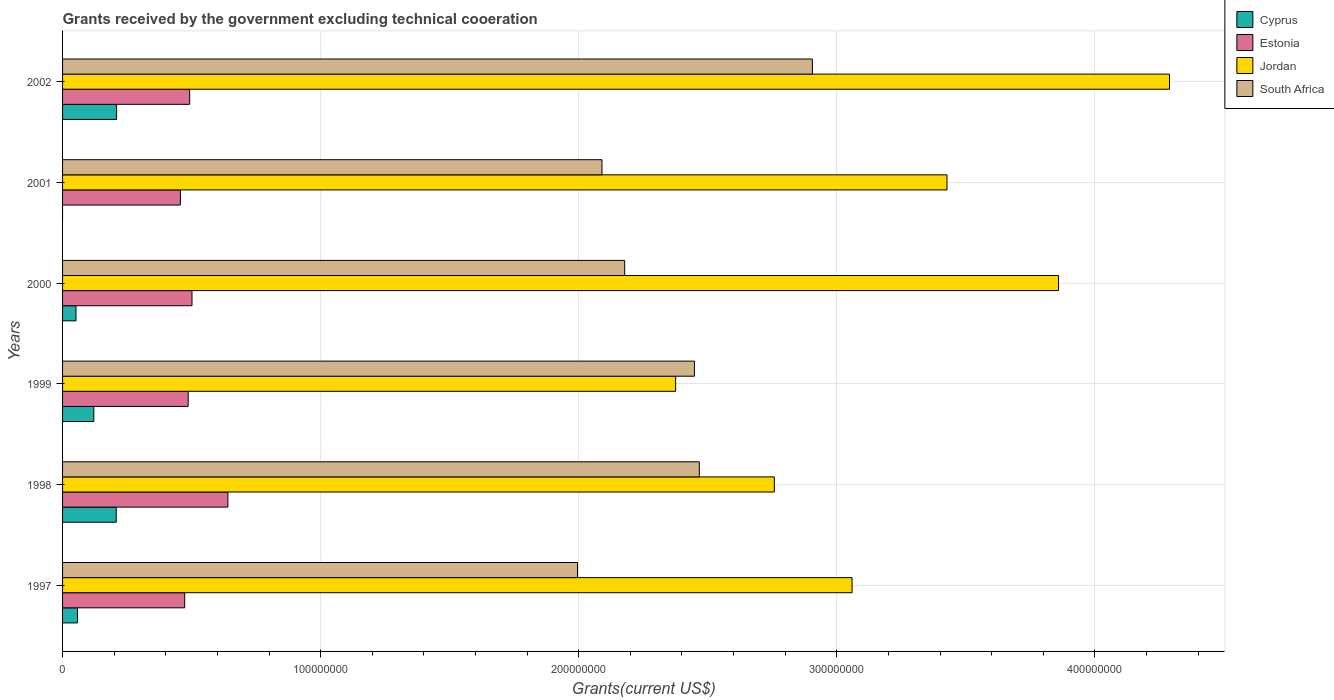How many different coloured bars are there?
Make the answer very short. 4. Are the number of bars per tick equal to the number of legend labels?
Keep it short and to the point. No. Are the number of bars on each tick of the Y-axis equal?
Your answer should be very brief. No. How many bars are there on the 1st tick from the top?
Your response must be concise. 4. How many bars are there on the 3rd tick from the bottom?
Your answer should be very brief. 4. In how many cases, is the number of bars for a given year not equal to the number of legend labels?
Your answer should be compact. 1. What is the total grants received by the government in South Africa in 1997?
Provide a short and direct response. 2.00e+08. Across all years, what is the maximum total grants received by the government in Cyprus?
Offer a very short reply. 2.09e+07. Across all years, what is the minimum total grants received by the government in South Africa?
Keep it short and to the point. 2.00e+08. What is the total total grants received by the government in Jordan in the graph?
Your answer should be compact. 1.98e+09. What is the difference between the total grants received by the government in Jordan in 1998 and the total grants received by the government in Estonia in 2002?
Provide a succinct answer. 2.27e+08. What is the average total grants received by the government in Jordan per year?
Provide a short and direct response. 3.29e+08. In the year 1998, what is the difference between the total grants received by the government in Jordan and total grants received by the government in Cyprus?
Ensure brevity in your answer.  2.55e+08. In how many years, is the total grants received by the government in South Africa greater than 200000000 US$?
Offer a very short reply. 5. What is the ratio of the total grants received by the government in Estonia in 1997 to that in 2001?
Your response must be concise. 1.04. Is the difference between the total grants received by the government in Jordan in 1999 and 2002 greater than the difference between the total grants received by the government in Cyprus in 1999 and 2002?
Offer a very short reply. No. What is the difference between the highest and the second highest total grants received by the government in South Africa?
Give a very brief answer. 4.38e+07. What is the difference between the highest and the lowest total grants received by the government in Estonia?
Give a very brief answer. 1.84e+07. Is it the case that in every year, the sum of the total grants received by the government in Cyprus and total grants received by the government in Estonia is greater than the total grants received by the government in South Africa?
Keep it short and to the point. No. How many bars are there?
Your answer should be compact. 23. Are the values on the major ticks of X-axis written in scientific E-notation?
Provide a short and direct response. No. Does the graph contain grids?
Make the answer very short. Yes. How many legend labels are there?
Keep it short and to the point. 4. What is the title of the graph?
Keep it short and to the point. Grants received by the government excluding technical cooeration. What is the label or title of the X-axis?
Your answer should be compact. Grants(current US$). What is the label or title of the Y-axis?
Provide a succinct answer. Years. What is the Grants(current US$) of Cyprus in 1997?
Ensure brevity in your answer.  5.78e+06. What is the Grants(current US$) in Estonia in 1997?
Offer a terse response. 4.73e+07. What is the Grants(current US$) of Jordan in 1997?
Ensure brevity in your answer.  3.06e+08. What is the Grants(current US$) of South Africa in 1997?
Make the answer very short. 2.00e+08. What is the Grants(current US$) of Cyprus in 1998?
Make the answer very short. 2.08e+07. What is the Grants(current US$) in Estonia in 1998?
Offer a terse response. 6.41e+07. What is the Grants(current US$) of Jordan in 1998?
Your answer should be compact. 2.76e+08. What is the Grants(current US$) of South Africa in 1998?
Give a very brief answer. 2.47e+08. What is the Grants(current US$) of Cyprus in 1999?
Your answer should be very brief. 1.21e+07. What is the Grants(current US$) in Estonia in 1999?
Your response must be concise. 4.87e+07. What is the Grants(current US$) of Jordan in 1999?
Offer a very short reply. 2.38e+08. What is the Grants(current US$) of South Africa in 1999?
Your answer should be compact. 2.45e+08. What is the Grants(current US$) of Cyprus in 2000?
Ensure brevity in your answer.  5.20e+06. What is the Grants(current US$) in Estonia in 2000?
Make the answer very short. 5.02e+07. What is the Grants(current US$) of Jordan in 2000?
Your response must be concise. 3.86e+08. What is the Grants(current US$) in South Africa in 2000?
Provide a succinct answer. 2.18e+08. What is the Grants(current US$) in Cyprus in 2001?
Make the answer very short. 0. What is the Grants(current US$) of Estonia in 2001?
Make the answer very short. 4.56e+07. What is the Grants(current US$) of Jordan in 2001?
Keep it short and to the point. 3.43e+08. What is the Grants(current US$) in South Africa in 2001?
Make the answer very short. 2.09e+08. What is the Grants(current US$) of Cyprus in 2002?
Offer a terse response. 2.09e+07. What is the Grants(current US$) in Estonia in 2002?
Your response must be concise. 4.92e+07. What is the Grants(current US$) in Jordan in 2002?
Offer a terse response. 4.29e+08. What is the Grants(current US$) in South Africa in 2002?
Keep it short and to the point. 2.91e+08. Across all years, what is the maximum Grants(current US$) in Cyprus?
Provide a short and direct response. 2.09e+07. Across all years, what is the maximum Grants(current US$) in Estonia?
Your answer should be compact. 6.41e+07. Across all years, what is the maximum Grants(current US$) of Jordan?
Offer a very short reply. 4.29e+08. Across all years, what is the maximum Grants(current US$) in South Africa?
Offer a terse response. 2.91e+08. Across all years, what is the minimum Grants(current US$) of Cyprus?
Give a very brief answer. 0. Across all years, what is the minimum Grants(current US$) in Estonia?
Make the answer very short. 4.56e+07. Across all years, what is the minimum Grants(current US$) in Jordan?
Offer a terse response. 2.38e+08. Across all years, what is the minimum Grants(current US$) in South Africa?
Offer a terse response. 2.00e+08. What is the total Grants(current US$) of Cyprus in the graph?
Your response must be concise. 6.48e+07. What is the total Grants(current US$) in Estonia in the graph?
Provide a succinct answer. 3.05e+08. What is the total Grants(current US$) in Jordan in the graph?
Provide a succinct answer. 1.98e+09. What is the total Grants(current US$) in South Africa in the graph?
Your response must be concise. 1.41e+09. What is the difference between the Grants(current US$) of Cyprus in 1997 and that in 1998?
Make the answer very short. -1.50e+07. What is the difference between the Grants(current US$) in Estonia in 1997 and that in 1998?
Your response must be concise. -1.67e+07. What is the difference between the Grants(current US$) of Jordan in 1997 and that in 1998?
Offer a terse response. 3.01e+07. What is the difference between the Grants(current US$) in South Africa in 1997 and that in 1998?
Your answer should be compact. -4.72e+07. What is the difference between the Grants(current US$) of Cyprus in 1997 and that in 1999?
Provide a short and direct response. -6.33e+06. What is the difference between the Grants(current US$) of Estonia in 1997 and that in 1999?
Your answer should be compact. -1.36e+06. What is the difference between the Grants(current US$) of Jordan in 1997 and that in 1999?
Your response must be concise. 6.84e+07. What is the difference between the Grants(current US$) in South Africa in 1997 and that in 1999?
Offer a very short reply. -4.53e+07. What is the difference between the Grants(current US$) in Cyprus in 1997 and that in 2000?
Provide a succinct answer. 5.80e+05. What is the difference between the Grants(current US$) of Estonia in 1997 and that in 2000?
Your answer should be compact. -2.83e+06. What is the difference between the Grants(current US$) in Jordan in 1997 and that in 2000?
Provide a succinct answer. -8.00e+07. What is the difference between the Grants(current US$) in South Africa in 1997 and that in 2000?
Your response must be concise. -1.83e+07. What is the difference between the Grants(current US$) of Estonia in 1997 and that in 2001?
Your answer should be very brief. 1.67e+06. What is the difference between the Grants(current US$) of Jordan in 1997 and that in 2001?
Give a very brief answer. -3.68e+07. What is the difference between the Grants(current US$) of South Africa in 1997 and that in 2001?
Give a very brief answer. -9.48e+06. What is the difference between the Grants(current US$) of Cyprus in 1997 and that in 2002?
Your answer should be compact. -1.52e+07. What is the difference between the Grants(current US$) in Estonia in 1997 and that in 2002?
Keep it short and to the point. -1.93e+06. What is the difference between the Grants(current US$) of Jordan in 1997 and that in 2002?
Give a very brief answer. -1.23e+08. What is the difference between the Grants(current US$) of South Africa in 1997 and that in 2002?
Ensure brevity in your answer.  -9.10e+07. What is the difference between the Grants(current US$) in Cyprus in 1998 and that in 1999?
Ensure brevity in your answer.  8.69e+06. What is the difference between the Grants(current US$) in Estonia in 1998 and that in 1999?
Provide a short and direct response. 1.54e+07. What is the difference between the Grants(current US$) of Jordan in 1998 and that in 1999?
Your answer should be very brief. 3.82e+07. What is the difference between the Grants(current US$) in South Africa in 1998 and that in 1999?
Keep it short and to the point. 1.90e+06. What is the difference between the Grants(current US$) in Cyprus in 1998 and that in 2000?
Offer a very short reply. 1.56e+07. What is the difference between the Grants(current US$) of Estonia in 1998 and that in 2000?
Ensure brevity in your answer.  1.39e+07. What is the difference between the Grants(current US$) in Jordan in 1998 and that in 2000?
Offer a very short reply. -1.10e+08. What is the difference between the Grants(current US$) in South Africa in 1998 and that in 2000?
Ensure brevity in your answer.  2.89e+07. What is the difference between the Grants(current US$) in Estonia in 1998 and that in 2001?
Keep it short and to the point. 1.84e+07. What is the difference between the Grants(current US$) of Jordan in 1998 and that in 2001?
Keep it short and to the point. -6.69e+07. What is the difference between the Grants(current US$) of South Africa in 1998 and that in 2001?
Make the answer very short. 3.77e+07. What is the difference between the Grants(current US$) of Cyprus in 1998 and that in 2002?
Your response must be concise. -1.40e+05. What is the difference between the Grants(current US$) in Estonia in 1998 and that in 2002?
Make the answer very short. 1.48e+07. What is the difference between the Grants(current US$) in Jordan in 1998 and that in 2002?
Your response must be concise. -1.53e+08. What is the difference between the Grants(current US$) in South Africa in 1998 and that in 2002?
Provide a short and direct response. -4.38e+07. What is the difference between the Grants(current US$) in Cyprus in 1999 and that in 2000?
Your answer should be very brief. 6.91e+06. What is the difference between the Grants(current US$) of Estonia in 1999 and that in 2000?
Your answer should be compact. -1.47e+06. What is the difference between the Grants(current US$) of Jordan in 1999 and that in 2000?
Your answer should be very brief. -1.48e+08. What is the difference between the Grants(current US$) of South Africa in 1999 and that in 2000?
Ensure brevity in your answer.  2.70e+07. What is the difference between the Grants(current US$) in Estonia in 1999 and that in 2001?
Your answer should be very brief. 3.03e+06. What is the difference between the Grants(current US$) of Jordan in 1999 and that in 2001?
Make the answer very short. -1.05e+08. What is the difference between the Grants(current US$) in South Africa in 1999 and that in 2001?
Make the answer very short. 3.58e+07. What is the difference between the Grants(current US$) in Cyprus in 1999 and that in 2002?
Offer a terse response. -8.83e+06. What is the difference between the Grants(current US$) of Estonia in 1999 and that in 2002?
Your answer should be very brief. -5.70e+05. What is the difference between the Grants(current US$) of Jordan in 1999 and that in 2002?
Your answer should be very brief. -1.91e+08. What is the difference between the Grants(current US$) of South Africa in 1999 and that in 2002?
Make the answer very short. -4.57e+07. What is the difference between the Grants(current US$) of Estonia in 2000 and that in 2001?
Your response must be concise. 4.50e+06. What is the difference between the Grants(current US$) of Jordan in 2000 and that in 2001?
Provide a succinct answer. 4.32e+07. What is the difference between the Grants(current US$) in South Africa in 2000 and that in 2001?
Ensure brevity in your answer.  8.80e+06. What is the difference between the Grants(current US$) in Cyprus in 2000 and that in 2002?
Provide a short and direct response. -1.57e+07. What is the difference between the Grants(current US$) of Estonia in 2000 and that in 2002?
Keep it short and to the point. 9.00e+05. What is the difference between the Grants(current US$) in Jordan in 2000 and that in 2002?
Offer a terse response. -4.30e+07. What is the difference between the Grants(current US$) in South Africa in 2000 and that in 2002?
Provide a succinct answer. -7.27e+07. What is the difference between the Grants(current US$) of Estonia in 2001 and that in 2002?
Make the answer very short. -3.60e+06. What is the difference between the Grants(current US$) in Jordan in 2001 and that in 2002?
Your response must be concise. -8.62e+07. What is the difference between the Grants(current US$) of South Africa in 2001 and that in 2002?
Your response must be concise. -8.15e+07. What is the difference between the Grants(current US$) in Cyprus in 1997 and the Grants(current US$) in Estonia in 1998?
Your answer should be compact. -5.83e+07. What is the difference between the Grants(current US$) of Cyprus in 1997 and the Grants(current US$) of Jordan in 1998?
Ensure brevity in your answer.  -2.70e+08. What is the difference between the Grants(current US$) of Cyprus in 1997 and the Grants(current US$) of South Africa in 1998?
Make the answer very short. -2.41e+08. What is the difference between the Grants(current US$) in Estonia in 1997 and the Grants(current US$) in Jordan in 1998?
Give a very brief answer. -2.28e+08. What is the difference between the Grants(current US$) in Estonia in 1997 and the Grants(current US$) in South Africa in 1998?
Your answer should be very brief. -1.99e+08. What is the difference between the Grants(current US$) of Jordan in 1997 and the Grants(current US$) of South Africa in 1998?
Give a very brief answer. 5.92e+07. What is the difference between the Grants(current US$) of Cyprus in 1997 and the Grants(current US$) of Estonia in 1999?
Keep it short and to the point. -4.29e+07. What is the difference between the Grants(current US$) in Cyprus in 1997 and the Grants(current US$) in Jordan in 1999?
Give a very brief answer. -2.32e+08. What is the difference between the Grants(current US$) in Cyprus in 1997 and the Grants(current US$) in South Africa in 1999?
Your answer should be compact. -2.39e+08. What is the difference between the Grants(current US$) of Estonia in 1997 and the Grants(current US$) of Jordan in 1999?
Offer a terse response. -1.90e+08. What is the difference between the Grants(current US$) of Estonia in 1997 and the Grants(current US$) of South Africa in 1999?
Offer a very short reply. -1.98e+08. What is the difference between the Grants(current US$) in Jordan in 1997 and the Grants(current US$) in South Africa in 1999?
Your answer should be very brief. 6.11e+07. What is the difference between the Grants(current US$) of Cyprus in 1997 and the Grants(current US$) of Estonia in 2000?
Offer a terse response. -4.44e+07. What is the difference between the Grants(current US$) in Cyprus in 1997 and the Grants(current US$) in Jordan in 2000?
Make the answer very short. -3.80e+08. What is the difference between the Grants(current US$) in Cyprus in 1997 and the Grants(current US$) in South Africa in 2000?
Keep it short and to the point. -2.12e+08. What is the difference between the Grants(current US$) in Estonia in 1997 and the Grants(current US$) in Jordan in 2000?
Your answer should be very brief. -3.39e+08. What is the difference between the Grants(current US$) of Estonia in 1997 and the Grants(current US$) of South Africa in 2000?
Your response must be concise. -1.70e+08. What is the difference between the Grants(current US$) of Jordan in 1997 and the Grants(current US$) of South Africa in 2000?
Provide a short and direct response. 8.81e+07. What is the difference between the Grants(current US$) of Cyprus in 1997 and the Grants(current US$) of Estonia in 2001?
Make the answer very short. -3.99e+07. What is the difference between the Grants(current US$) in Cyprus in 1997 and the Grants(current US$) in Jordan in 2001?
Offer a very short reply. -3.37e+08. What is the difference between the Grants(current US$) of Cyprus in 1997 and the Grants(current US$) of South Africa in 2001?
Keep it short and to the point. -2.03e+08. What is the difference between the Grants(current US$) in Estonia in 1997 and the Grants(current US$) in Jordan in 2001?
Keep it short and to the point. -2.95e+08. What is the difference between the Grants(current US$) of Estonia in 1997 and the Grants(current US$) of South Africa in 2001?
Ensure brevity in your answer.  -1.62e+08. What is the difference between the Grants(current US$) of Jordan in 1997 and the Grants(current US$) of South Africa in 2001?
Provide a succinct answer. 9.69e+07. What is the difference between the Grants(current US$) in Cyprus in 1997 and the Grants(current US$) in Estonia in 2002?
Offer a terse response. -4.35e+07. What is the difference between the Grants(current US$) in Cyprus in 1997 and the Grants(current US$) in Jordan in 2002?
Keep it short and to the point. -4.23e+08. What is the difference between the Grants(current US$) of Cyprus in 1997 and the Grants(current US$) of South Africa in 2002?
Make the answer very short. -2.85e+08. What is the difference between the Grants(current US$) in Estonia in 1997 and the Grants(current US$) in Jordan in 2002?
Provide a succinct answer. -3.82e+08. What is the difference between the Grants(current US$) in Estonia in 1997 and the Grants(current US$) in South Africa in 2002?
Give a very brief answer. -2.43e+08. What is the difference between the Grants(current US$) of Jordan in 1997 and the Grants(current US$) of South Africa in 2002?
Provide a succinct answer. 1.54e+07. What is the difference between the Grants(current US$) of Cyprus in 1998 and the Grants(current US$) of Estonia in 1999?
Make the answer very short. -2.79e+07. What is the difference between the Grants(current US$) in Cyprus in 1998 and the Grants(current US$) in Jordan in 1999?
Keep it short and to the point. -2.17e+08. What is the difference between the Grants(current US$) in Cyprus in 1998 and the Grants(current US$) in South Africa in 1999?
Offer a terse response. -2.24e+08. What is the difference between the Grants(current US$) in Estonia in 1998 and the Grants(current US$) in Jordan in 1999?
Your answer should be compact. -1.73e+08. What is the difference between the Grants(current US$) of Estonia in 1998 and the Grants(current US$) of South Africa in 1999?
Your response must be concise. -1.81e+08. What is the difference between the Grants(current US$) of Jordan in 1998 and the Grants(current US$) of South Africa in 1999?
Offer a very short reply. 3.10e+07. What is the difference between the Grants(current US$) of Cyprus in 1998 and the Grants(current US$) of Estonia in 2000?
Your answer should be compact. -2.94e+07. What is the difference between the Grants(current US$) of Cyprus in 1998 and the Grants(current US$) of Jordan in 2000?
Your response must be concise. -3.65e+08. What is the difference between the Grants(current US$) of Cyprus in 1998 and the Grants(current US$) of South Africa in 2000?
Make the answer very short. -1.97e+08. What is the difference between the Grants(current US$) of Estonia in 1998 and the Grants(current US$) of Jordan in 2000?
Provide a short and direct response. -3.22e+08. What is the difference between the Grants(current US$) of Estonia in 1998 and the Grants(current US$) of South Africa in 2000?
Make the answer very short. -1.54e+08. What is the difference between the Grants(current US$) of Jordan in 1998 and the Grants(current US$) of South Africa in 2000?
Give a very brief answer. 5.80e+07. What is the difference between the Grants(current US$) in Cyprus in 1998 and the Grants(current US$) in Estonia in 2001?
Give a very brief answer. -2.48e+07. What is the difference between the Grants(current US$) in Cyprus in 1998 and the Grants(current US$) in Jordan in 2001?
Your response must be concise. -3.22e+08. What is the difference between the Grants(current US$) of Cyprus in 1998 and the Grants(current US$) of South Africa in 2001?
Provide a succinct answer. -1.88e+08. What is the difference between the Grants(current US$) of Estonia in 1998 and the Grants(current US$) of Jordan in 2001?
Your response must be concise. -2.79e+08. What is the difference between the Grants(current US$) of Estonia in 1998 and the Grants(current US$) of South Africa in 2001?
Make the answer very short. -1.45e+08. What is the difference between the Grants(current US$) in Jordan in 1998 and the Grants(current US$) in South Africa in 2001?
Your response must be concise. 6.68e+07. What is the difference between the Grants(current US$) of Cyprus in 1998 and the Grants(current US$) of Estonia in 2002?
Offer a terse response. -2.84e+07. What is the difference between the Grants(current US$) in Cyprus in 1998 and the Grants(current US$) in Jordan in 2002?
Your answer should be very brief. -4.08e+08. What is the difference between the Grants(current US$) of Cyprus in 1998 and the Grants(current US$) of South Africa in 2002?
Your answer should be compact. -2.70e+08. What is the difference between the Grants(current US$) in Estonia in 1998 and the Grants(current US$) in Jordan in 2002?
Provide a succinct answer. -3.65e+08. What is the difference between the Grants(current US$) in Estonia in 1998 and the Grants(current US$) in South Africa in 2002?
Your answer should be very brief. -2.26e+08. What is the difference between the Grants(current US$) of Jordan in 1998 and the Grants(current US$) of South Africa in 2002?
Offer a very short reply. -1.48e+07. What is the difference between the Grants(current US$) in Cyprus in 1999 and the Grants(current US$) in Estonia in 2000?
Your answer should be very brief. -3.80e+07. What is the difference between the Grants(current US$) of Cyprus in 1999 and the Grants(current US$) of Jordan in 2000?
Offer a very short reply. -3.74e+08. What is the difference between the Grants(current US$) in Cyprus in 1999 and the Grants(current US$) in South Africa in 2000?
Ensure brevity in your answer.  -2.06e+08. What is the difference between the Grants(current US$) of Estonia in 1999 and the Grants(current US$) of Jordan in 2000?
Your answer should be compact. -3.37e+08. What is the difference between the Grants(current US$) in Estonia in 1999 and the Grants(current US$) in South Africa in 2000?
Offer a very short reply. -1.69e+08. What is the difference between the Grants(current US$) in Jordan in 1999 and the Grants(current US$) in South Africa in 2000?
Provide a short and direct response. 1.97e+07. What is the difference between the Grants(current US$) of Cyprus in 1999 and the Grants(current US$) of Estonia in 2001?
Keep it short and to the point. -3.35e+07. What is the difference between the Grants(current US$) in Cyprus in 1999 and the Grants(current US$) in Jordan in 2001?
Provide a succinct answer. -3.31e+08. What is the difference between the Grants(current US$) of Cyprus in 1999 and the Grants(current US$) of South Africa in 2001?
Offer a terse response. -1.97e+08. What is the difference between the Grants(current US$) of Estonia in 1999 and the Grants(current US$) of Jordan in 2001?
Make the answer very short. -2.94e+08. What is the difference between the Grants(current US$) of Estonia in 1999 and the Grants(current US$) of South Africa in 2001?
Your response must be concise. -1.60e+08. What is the difference between the Grants(current US$) in Jordan in 1999 and the Grants(current US$) in South Africa in 2001?
Your response must be concise. 2.85e+07. What is the difference between the Grants(current US$) of Cyprus in 1999 and the Grants(current US$) of Estonia in 2002?
Make the answer very short. -3.71e+07. What is the difference between the Grants(current US$) in Cyprus in 1999 and the Grants(current US$) in Jordan in 2002?
Give a very brief answer. -4.17e+08. What is the difference between the Grants(current US$) of Cyprus in 1999 and the Grants(current US$) of South Africa in 2002?
Make the answer very short. -2.78e+08. What is the difference between the Grants(current US$) in Estonia in 1999 and the Grants(current US$) in Jordan in 2002?
Provide a succinct answer. -3.80e+08. What is the difference between the Grants(current US$) of Estonia in 1999 and the Grants(current US$) of South Africa in 2002?
Keep it short and to the point. -2.42e+08. What is the difference between the Grants(current US$) in Jordan in 1999 and the Grants(current US$) in South Africa in 2002?
Offer a terse response. -5.30e+07. What is the difference between the Grants(current US$) in Cyprus in 2000 and the Grants(current US$) in Estonia in 2001?
Provide a short and direct response. -4.04e+07. What is the difference between the Grants(current US$) of Cyprus in 2000 and the Grants(current US$) of Jordan in 2001?
Make the answer very short. -3.37e+08. What is the difference between the Grants(current US$) in Cyprus in 2000 and the Grants(current US$) in South Africa in 2001?
Keep it short and to the point. -2.04e+08. What is the difference between the Grants(current US$) of Estonia in 2000 and the Grants(current US$) of Jordan in 2001?
Make the answer very short. -2.93e+08. What is the difference between the Grants(current US$) of Estonia in 2000 and the Grants(current US$) of South Africa in 2001?
Provide a succinct answer. -1.59e+08. What is the difference between the Grants(current US$) of Jordan in 2000 and the Grants(current US$) of South Africa in 2001?
Give a very brief answer. 1.77e+08. What is the difference between the Grants(current US$) in Cyprus in 2000 and the Grants(current US$) in Estonia in 2002?
Make the answer very short. -4.40e+07. What is the difference between the Grants(current US$) of Cyprus in 2000 and the Grants(current US$) of Jordan in 2002?
Ensure brevity in your answer.  -4.24e+08. What is the difference between the Grants(current US$) of Cyprus in 2000 and the Grants(current US$) of South Africa in 2002?
Your answer should be compact. -2.85e+08. What is the difference between the Grants(current US$) of Estonia in 2000 and the Grants(current US$) of Jordan in 2002?
Ensure brevity in your answer.  -3.79e+08. What is the difference between the Grants(current US$) of Estonia in 2000 and the Grants(current US$) of South Africa in 2002?
Provide a succinct answer. -2.40e+08. What is the difference between the Grants(current US$) in Jordan in 2000 and the Grants(current US$) in South Africa in 2002?
Keep it short and to the point. 9.54e+07. What is the difference between the Grants(current US$) in Estonia in 2001 and the Grants(current US$) in Jordan in 2002?
Provide a short and direct response. -3.83e+08. What is the difference between the Grants(current US$) of Estonia in 2001 and the Grants(current US$) of South Africa in 2002?
Your answer should be compact. -2.45e+08. What is the difference between the Grants(current US$) in Jordan in 2001 and the Grants(current US$) in South Africa in 2002?
Ensure brevity in your answer.  5.22e+07. What is the average Grants(current US$) in Cyprus per year?
Offer a terse response. 1.08e+07. What is the average Grants(current US$) in Estonia per year?
Your answer should be compact. 5.09e+07. What is the average Grants(current US$) in Jordan per year?
Provide a short and direct response. 3.29e+08. What is the average Grants(current US$) of South Africa per year?
Keep it short and to the point. 2.35e+08. In the year 1997, what is the difference between the Grants(current US$) in Cyprus and Grants(current US$) in Estonia?
Offer a terse response. -4.15e+07. In the year 1997, what is the difference between the Grants(current US$) of Cyprus and Grants(current US$) of Jordan?
Your answer should be very brief. -3.00e+08. In the year 1997, what is the difference between the Grants(current US$) of Cyprus and Grants(current US$) of South Africa?
Your answer should be very brief. -1.94e+08. In the year 1997, what is the difference between the Grants(current US$) of Estonia and Grants(current US$) of Jordan?
Offer a terse response. -2.59e+08. In the year 1997, what is the difference between the Grants(current US$) in Estonia and Grants(current US$) in South Africa?
Make the answer very short. -1.52e+08. In the year 1997, what is the difference between the Grants(current US$) in Jordan and Grants(current US$) in South Africa?
Provide a succinct answer. 1.06e+08. In the year 1998, what is the difference between the Grants(current US$) of Cyprus and Grants(current US$) of Estonia?
Provide a short and direct response. -4.33e+07. In the year 1998, what is the difference between the Grants(current US$) of Cyprus and Grants(current US$) of Jordan?
Make the answer very short. -2.55e+08. In the year 1998, what is the difference between the Grants(current US$) in Cyprus and Grants(current US$) in South Africa?
Offer a very short reply. -2.26e+08. In the year 1998, what is the difference between the Grants(current US$) of Estonia and Grants(current US$) of Jordan?
Make the answer very short. -2.12e+08. In the year 1998, what is the difference between the Grants(current US$) of Estonia and Grants(current US$) of South Africa?
Keep it short and to the point. -1.83e+08. In the year 1998, what is the difference between the Grants(current US$) of Jordan and Grants(current US$) of South Africa?
Keep it short and to the point. 2.91e+07. In the year 1999, what is the difference between the Grants(current US$) of Cyprus and Grants(current US$) of Estonia?
Provide a short and direct response. -3.66e+07. In the year 1999, what is the difference between the Grants(current US$) of Cyprus and Grants(current US$) of Jordan?
Ensure brevity in your answer.  -2.25e+08. In the year 1999, what is the difference between the Grants(current US$) of Cyprus and Grants(current US$) of South Africa?
Offer a terse response. -2.33e+08. In the year 1999, what is the difference between the Grants(current US$) of Estonia and Grants(current US$) of Jordan?
Ensure brevity in your answer.  -1.89e+08. In the year 1999, what is the difference between the Grants(current US$) in Estonia and Grants(current US$) in South Africa?
Your response must be concise. -1.96e+08. In the year 1999, what is the difference between the Grants(current US$) of Jordan and Grants(current US$) of South Africa?
Your response must be concise. -7.28e+06. In the year 2000, what is the difference between the Grants(current US$) in Cyprus and Grants(current US$) in Estonia?
Make the answer very short. -4.50e+07. In the year 2000, what is the difference between the Grants(current US$) in Cyprus and Grants(current US$) in Jordan?
Provide a short and direct response. -3.81e+08. In the year 2000, what is the difference between the Grants(current US$) of Cyprus and Grants(current US$) of South Africa?
Ensure brevity in your answer.  -2.13e+08. In the year 2000, what is the difference between the Grants(current US$) in Estonia and Grants(current US$) in Jordan?
Keep it short and to the point. -3.36e+08. In the year 2000, what is the difference between the Grants(current US$) in Estonia and Grants(current US$) in South Africa?
Give a very brief answer. -1.68e+08. In the year 2000, what is the difference between the Grants(current US$) of Jordan and Grants(current US$) of South Africa?
Keep it short and to the point. 1.68e+08. In the year 2001, what is the difference between the Grants(current US$) in Estonia and Grants(current US$) in Jordan?
Your response must be concise. -2.97e+08. In the year 2001, what is the difference between the Grants(current US$) in Estonia and Grants(current US$) in South Africa?
Ensure brevity in your answer.  -1.63e+08. In the year 2001, what is the difference between the Grants(current US$) of Jordan and Grants(current US$) of South Africa?
Ensure brevity in your answer.  1.34e+08. In the year 2002, what is the difference between the Grants(current US$) of Cyprus and Grants(current US$) of Estonia?
Your response must be concise. -2.83e+07. In the year 2002, what is the difference between the Grants(current US$) of Cyprus and Grants(current US$) of Jordan?
Provide a short and direct response. -4.08e+08. In the year 2002, what is the difference between the Grants(current US$) of Cyprus and Grants(current US$) of South Africa?
Offer a very short reply. -2.70e+08. In the year 2002, what is the difference between the Grants(current US$) of Estonia and Grants(current US$) of Jordan?
Your response must be concise. -3.80e+08. In the year 2002, what is the difference between the Grants(current US$) in Estonia and Grants(current US$) in South Africa?
Provide a short and direct response. -2.41e+08. In the year 2002, what is the difference between the Grants(current US$) in Jordan and Grants(current US$) in South Africa?
Your response must be concise. 1.38e+08. What is the ratio of the Grants(current US$) in Cyprus in 1997 to that in 1998?
Provide a succinct answer. 0.28. What is the ratio of the Grants(current US$) of Estonia in 1997 to that in 1998?
Keep it short and to the point. 0.74. What is the ratio of the Grants(current US$) in Jordan in 1997 to that in 1998?
Give a very brief answer. 1.11. What is the ratio of the Grants(current US$) in South Africa in 1997 to that in 1998?
Make the answer very short. 0.81. What is the ratio of the Grants(current US$) in Cyprus in 1997 to that in 1999?
Keep it short and to the point. 0.48. What is the ratio of the Grants(current US$) of Estonia in 1997 to that in 1999?
Ensure brevity in your answer.  0.97. What is the ratio of the Grants(current US$) in Jordan in 1997 to that in 1999?
Provide a short and direct response. 1.29. What is the ratio of the Grants(current US$) of South Africa in 1997 to that in 1999?
Your answer should be very brief. 0.81. What is the ratio of the Grants(current US$) in Cyprus in 1997 to that in 2000?
Your answer should be very brief. 1.11. What is the ratio of the Grants(current US$) of Estonia in 1997 to that in 2000?
Provide a succinct answer. 0.94. What is the ratio of the Grants(current US$) in Jordan in 1997 to that in 2000?
Your answer should be very brief. 0.79. What is the ratio of the Grants(current US$) in South Africa in 1997 to that in 2000?
Provide a short and direct response. 0.92. What is the ratio of the Grants(current US$) of Estonia in 1997 to that in 2001?
Offer a very short reply. 1.04. What is the ratio of the Grants(current US$) in Jordan in 1997 to that in 2001?
Your answer should be compact. 0.89. What is the ratio of the Grants(current US$) in South Africa in 1997 to that in 2001?
Your response must be concise. 0.95. What is the ratio of the Grants(current US$) of Cyprus in 1997 to that in 2002?
Provide a short and direct response. 0.28. What is the ratio of the Grants(current US$) of Estonia in 1997 to that in 2002?
Give a very brief answer. 0.96. What is the ratio of the Grants(current US$) in Jordan in 1997 to that in 2002?
Give a very brief answer. 0.71. What is the ratio of the Grants(current US$) of South Africa in 1997 to that in 2002?
Make the answer very short. 0.69. What is the ratio of the Grants(current US$) of Cyprus in 1998 to that in 1999?
Provide a succinct answer. 1.72. What is the ratio of the Grants(current US$) of Estonia in 1998 to that in 1999?
Provide a succinct answer. 1.32. What is the ratio of the Grants(current US$) in Jordan in 1998 to that in 1999?
Keep it short and to the point. 1.16. What is the ratio of the Grants(current US$) of South Africa in 1998 to that in 1999?
Keep it short and to the point. 1.01. What is the ratio of the Grants(current US$) in Cyprus in 1998 to that in 2000?
Provide a succinct answer. 4. What is the ratio of the Grants(current US$) in Estonia in 1998 to that in 2000?
Ensure brevity in your answer.  1.28. What is the ratio of the Grants(current US$) of Jordan in 1998 to that in 2000?
Keep it short and to the point. 0.71. What is the ratio of the Grants(current US$) in South Africa in 1998 to that in 2000?
Keep it short and to the point. 1.13. What is the ratio of the Grants(current US$) in Estonia in 1998 to that in 2001?
Provide a short and direct response. 1.4. What is the ratio of the Grants(current US$) in Jordan in 1998 to that in 2001?
Offer a terse response. 0.8. What is the ratio of the Grants(current US$) of South Africa in 1998 to that in 2001?
Keep it short and to the point. 1.18. What is the ratio of the Grants(current US$) of Cyprus in 1998 to that in 2002?
Provide a succinct answer. 0.99. What is the ratio of the Grants(current US$) of Estonia in 1998 to that in 2002?
Make the answer very short. 1.3. What is the ratio of the Grants(current US$) in Jordan in 1998 to that in 2002?
Your answer should be very brief. 0.64. What is the ratio of the Grants(current US$) in South Africa in 1998 to that in 2002?
Your answer should be very brief. 0.85. What is the ratio of the Grants(current US$) in Cyprus in 1999 to that in 2000?
Your answer should be very brief. 2.33. What is the ratio of the Grants(current US$) of Estonia in 1999 to that in 2000?
Keep it short and to the point. 0.97. What is the ratio of the Grants(current US$) of Jordan in 1999 to that in 2000?
Your answer should be compact. 0.62. What is the ratio of the Grants(current US$) in South Africa in 1999 to that in 2000?
Provide a short and direct response. 1.12. What is the ratio of the Grants(current US$) of Estonia in 1999 to that in 2001?
Provide a succinct answer. 1.07. What is the ratio of the Grants(current US$) of Jordan in 1999 to that in 2001?
Offer a very short reply. 0.69. What is the ratio of the Grants(current US$) of South Africa in 1999 to that in 2001?
Provide a short and direct response. 1.17. What is the ratio of the Grants(current US$) in Cyprus in 1999 to that in 2002?
Your response must be concise. 0.58. What is the ratio of the Grants(current US$) in Estonia in 1999 to that in 2002?
Your answer should be compact. 0.99. What is the ratio of the Grants(current US$) in Jordan in 1999 to that in 2002?
Provide a short and direct response. 0.55. What is the ratio of the Grants(current US$) in South Africa in 1999 to that in 2002?
Make the answer very short. 0.84. What is the ratio of the Grants(current US$) in Estonia in 2000 to that in 2001?
Offer a terse response. 1.1. What is the ratio of the Grants(current US$) in Jordan in 2000 to that in 2001?
Make the answer very short. 1.13. What is the ratio of the Grants(current US$) of South Africa in 2000 to that in 2001?
Give a very brief answer. 1.04. What is the ratio of the Grants(current US$) of Cyprus in 2000 to that in 2002?
Provide a short and direct response. 0.25. What is the ratio of the Grants(current US$) in Estonia in 2000 to that in 2002?
Provide a short and direct response. 1.02. What is the ratio of the Grants(current US$) in Jordan in 2000 to that in 2002?
Provide a succinct answer. 0.9. What is the ratio of the Grants(current US$) in South Africa in 2000 to that in 2002?
Keep it short and to the point. 0.75. What is the ratio of the Grants(current US$) in Estonia in 2001 to that in 2002?
Give a very brief answer. 0.93. What is the ratio of the Grants(current US$) of Jordan in 2001 to that in 2002?
Your answer should be very brief. 0.8. What is the ratio of the Grants(current US$) in South Africa in 2001 to that in 2002?
Give a very brief answer. 0.72. What is the difference between the highest and the second highest Grants(current US$) in Cyprus?
Your answer should be very brief. 1.40e+05. What is the difference between the highest and the second highest Grants(current US$) of Estonia?
Provide a succinct answer. 1.39e+07. What is the difference between the highest and the second highest Grants(current US$) in Jordan?
Offer a very short reply. 4.30e+07. What is the difference between the highest and the second highest Grants(current US$) of South Africa?
Offer a very short reply. 4.38e+07. What is the difference between the highest and the lowest Grants(current US$) in Cyprus?
Ensure brevity in your answer.  2.09e+07. What is the difference between the highest and the lowest Grants(current US$) in Estonia?
Provide a short and direct response. 1.84e+07. What is the difference between the highest and the lowest Grants(current US$) of Jordan?
Your answer should be very brief. 1.91e+08. What is the difference between the highest and the lowest Grants(current US$) in South Africa?
Make the answer very short. 9.10e+07. 